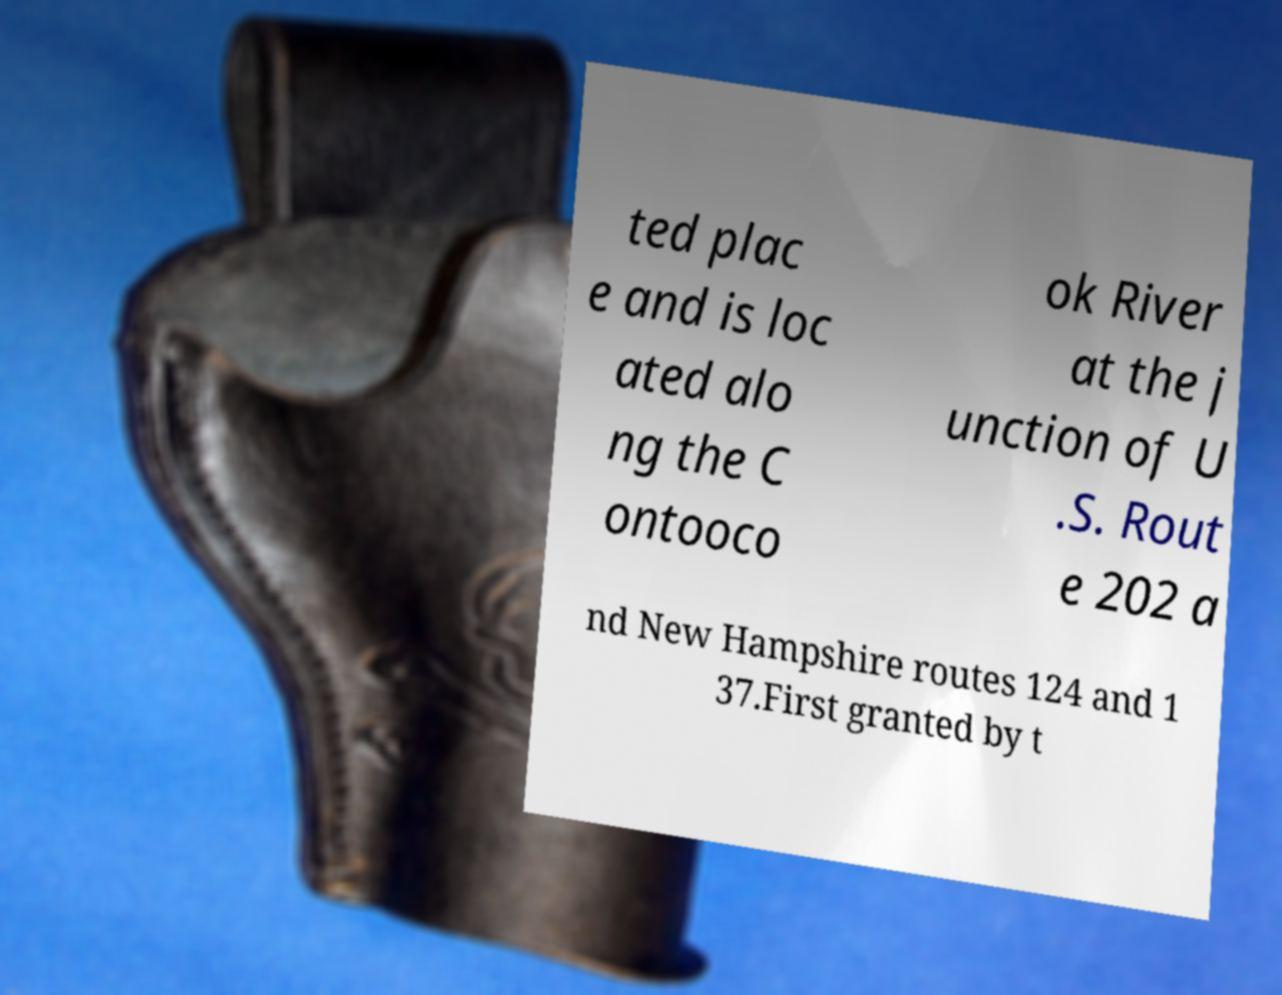For documentation purposes, I need the text within this image transcribed. Could you provide that? ted plac e and is loc ated alo ng the C ontooco ok River at the j unction of U .S. Rout e 202 a nd New Hampshire routes 124 and 1 37.First granted by t 